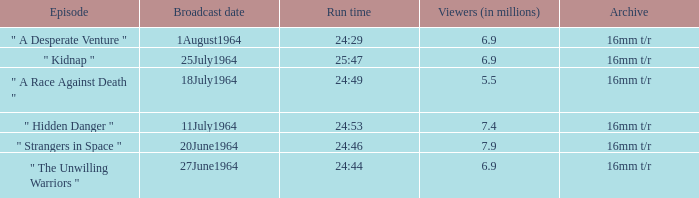What episode aired on 11july1964? " Hidden Danger ". 